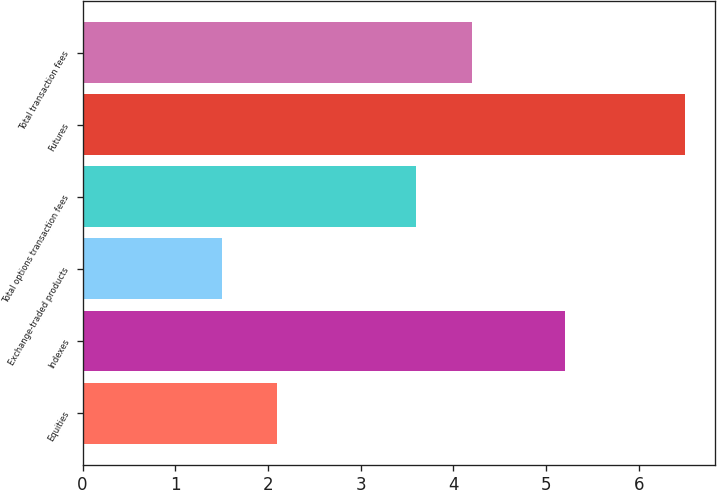Convert chart to OTSL. <chart><loc_0><loc_0><loc_500><loc_500><bar_chart><fcel>Equities<fcel>Indexes<fcel>Exchange-traded products<fcel>Total options transaction fees<fcel>Futures<fcel>Total transaction fees<nl><fcel>2.1<fcel>5.2<fcel>1.5<fcel>3.6<fcel>6.5<fcel>4.2<nl></chart> 